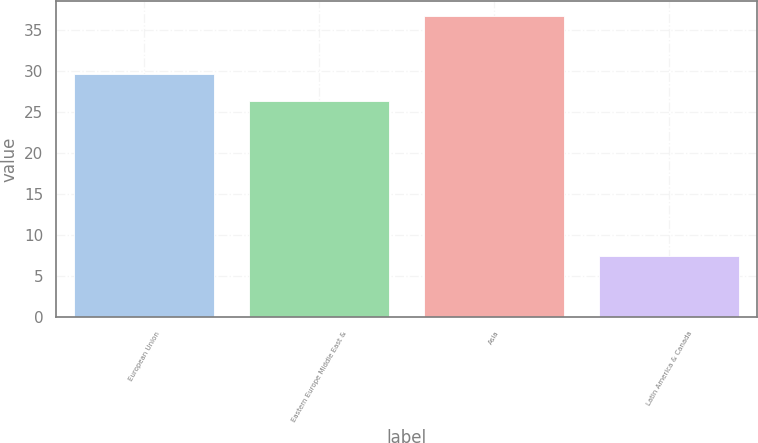Convert chart to OTSL. <chart><loc_0><loc_0><loc_500><loc_500><bar_chart><fcel>European Union<fcel>Eastern Europe Middle East &<fcel>Asia<fcel>Latin America & Canada<nl><fcel>29.6<fcel>26.3<fcel>36.7<fcel>7.4<nl></chart> 